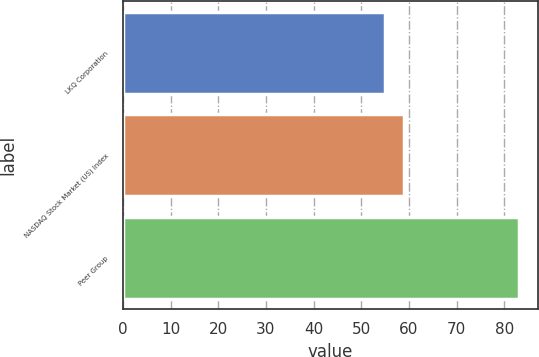Convert chart. <chart><loc_0><loc_0><loc_500><loc_500><bar_chart><fcel>LKQ Corporation<fcel>NASDAQ Stock Market (US) Index<fcel>Peer Group<nl><fcel>55<fcel>59<fcel>83<nl></chart> 